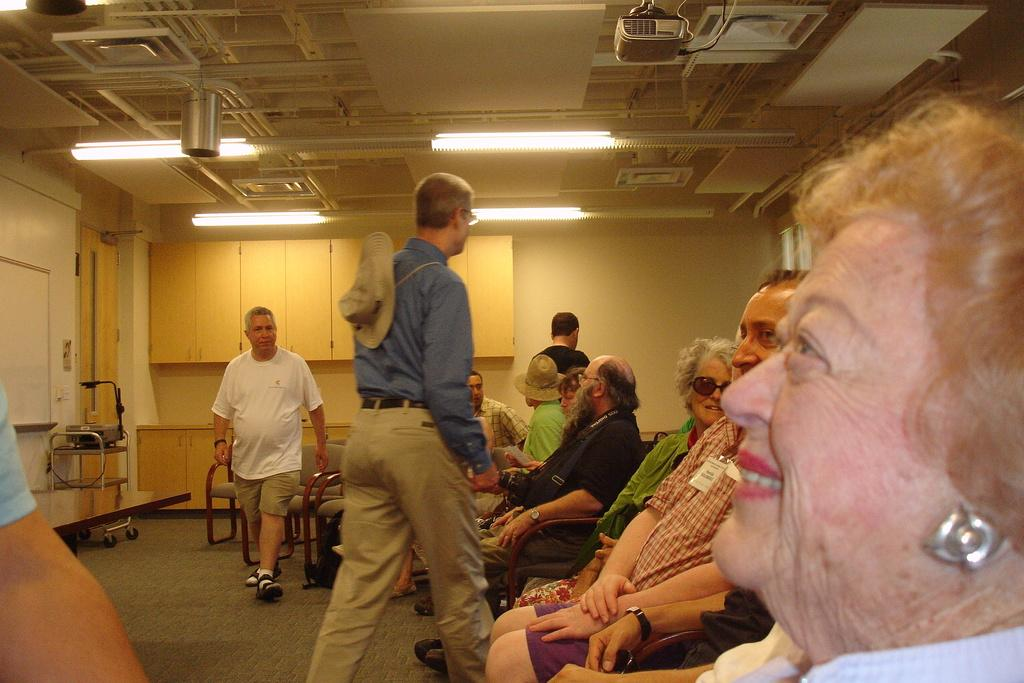What are the people in the image doing? The people in the image are sitting on chairs. What can be seen behind the people? There is a wall in the image. What is providing illumination in the image? There are lights in the image. What device is located at the front top of the image? There is a projector in the front top of the image. What type of ship can be seen sailing in the background of the image? There is no ship present in the image; it features people sitting on chairs, a wall, lights, and a projector. 